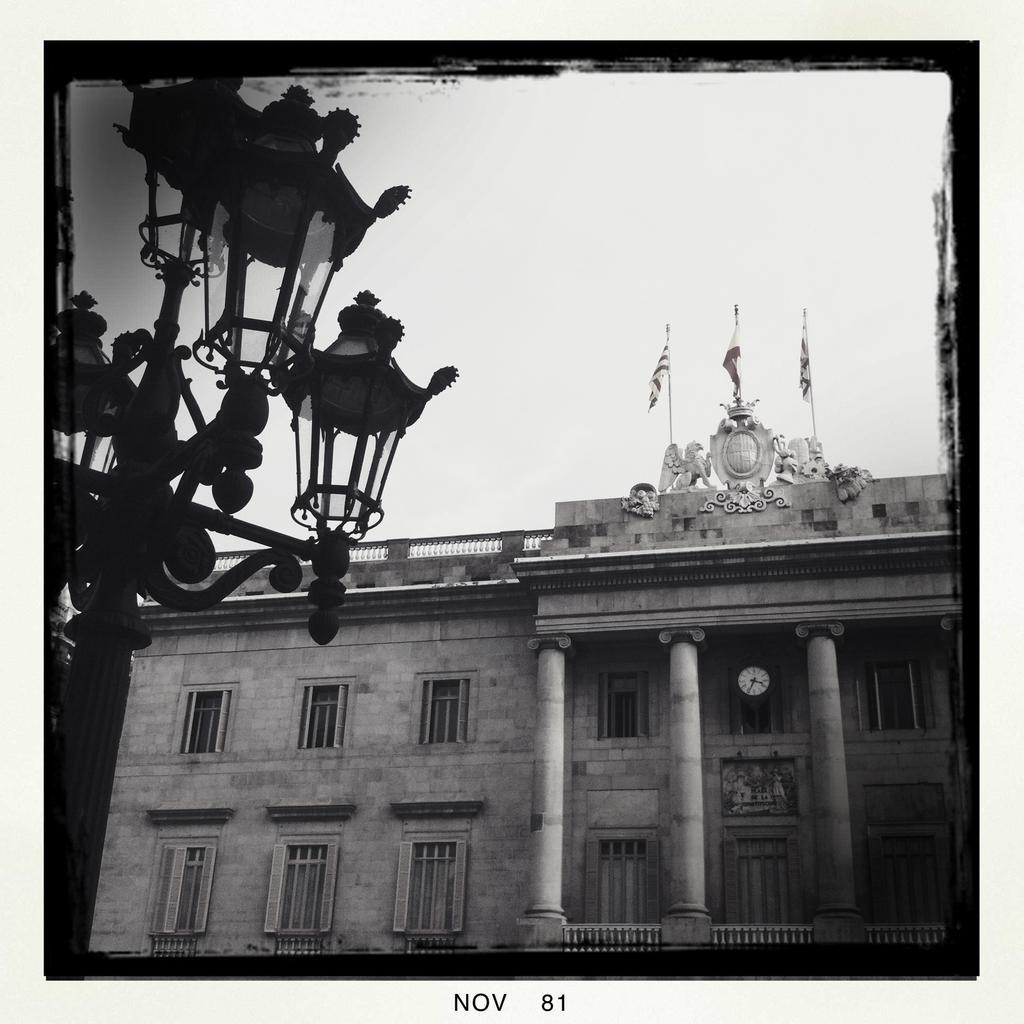How would you summarize this image in a sentence or two? In this picture I can observe some lamps fixed to the poles on the left side. There is a building and I can observe three pillars. There are three flags on the top of the building. In the background there is a sky. This is a black and white image. 